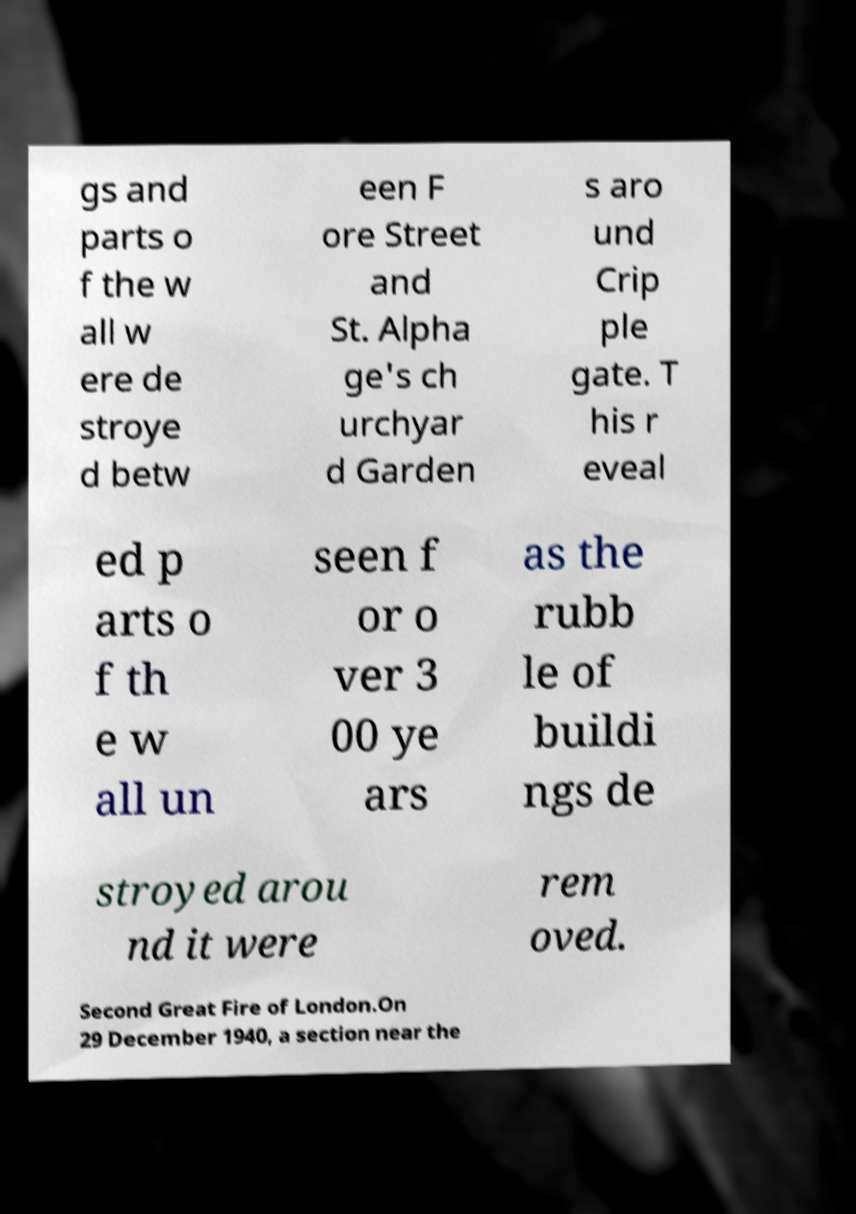There's text embedded in this image that I need extracted. Can you transcribe it verbatim? gs and parts o f the w all w ere de stroye d betw een F ore Street and St. Alpha ge's ch urchyar d Garden s aro und Crip ple gate. T his r eveal ed p arts o f th e w all un seen f or o ver 3 00 ye ars as the rubb le of buildi ngs de stroyed arou nd it were rem oved. Second Great Fire of London.On 29 December 1940, a section near the 